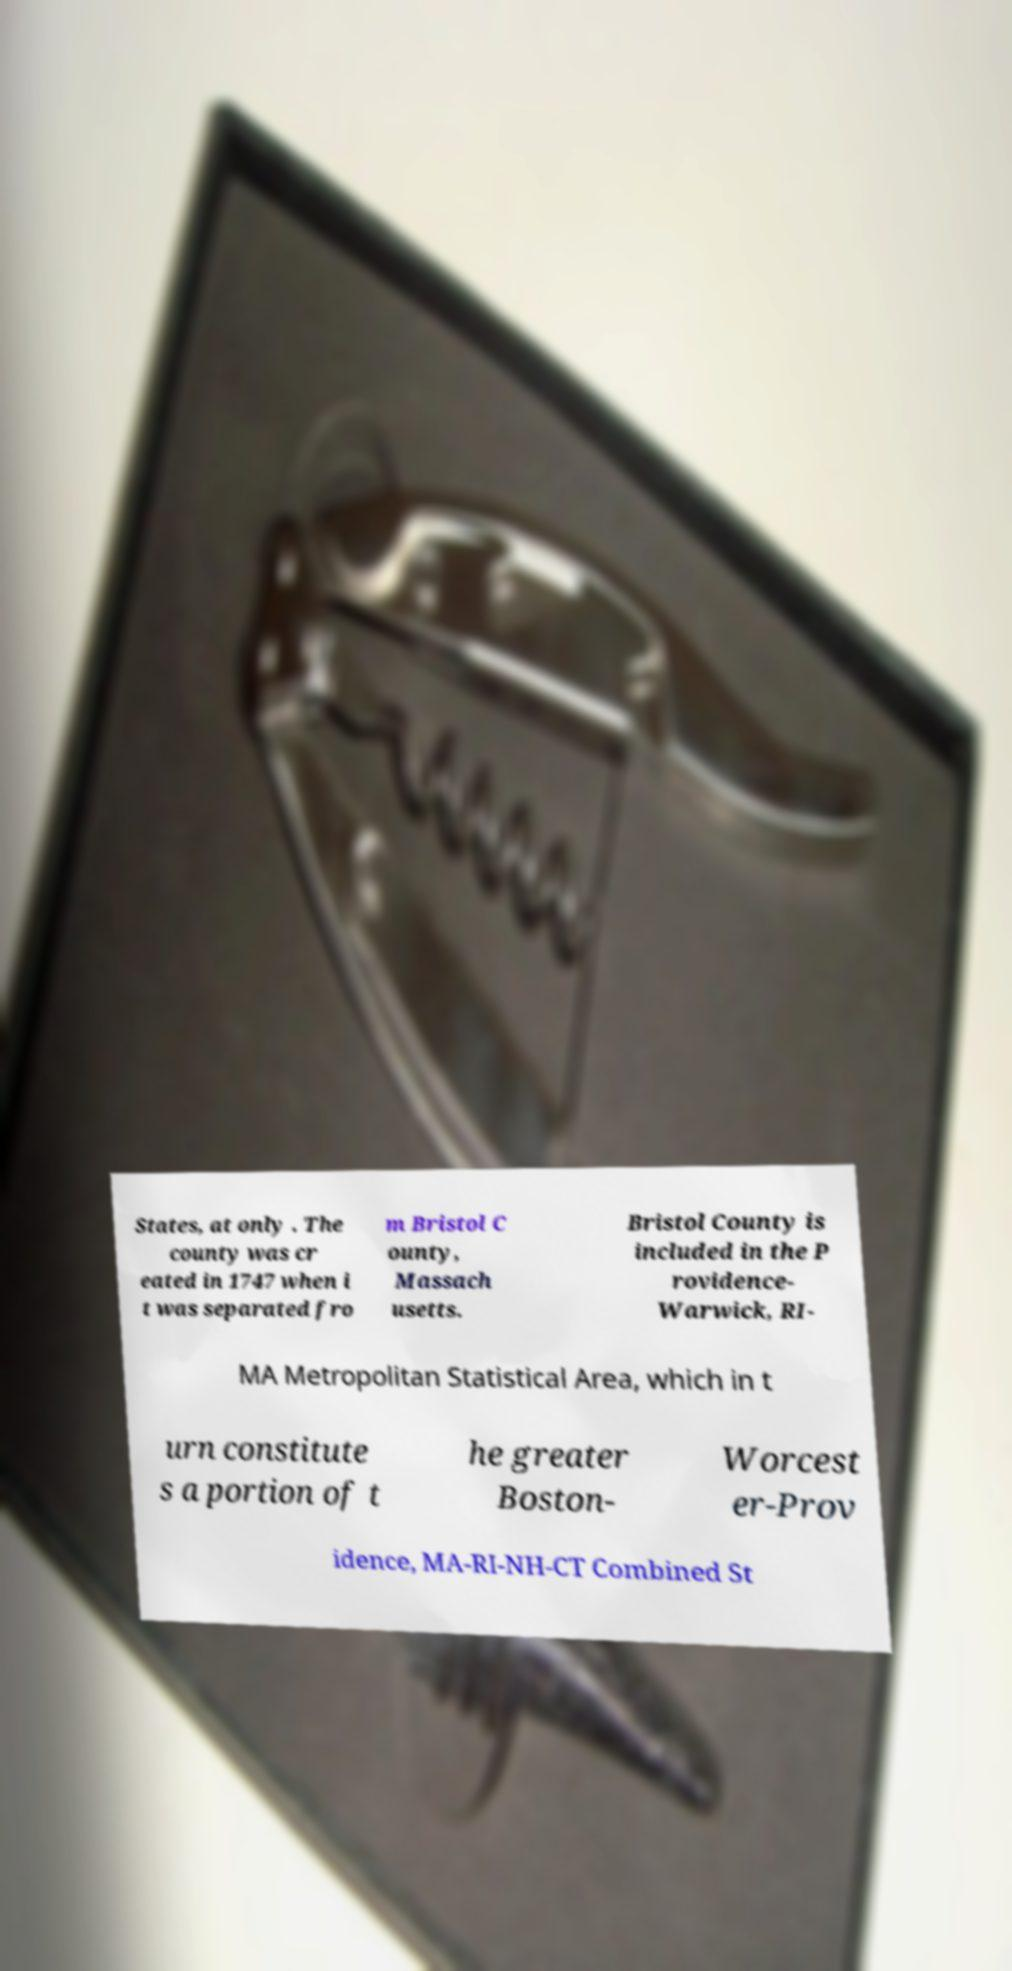Please read and relay the text visible in this image. What does it say? States, at only . The county was cr eated in 1747 when i t was separated fro m Bristol C ounty, Massach usetts. Bristol County is included in the P rovidence- Warwick, RI- MA Metropolitan Statistical Area, which in t urn constitute s a portion of t he greater Boston- Worcest er-Prov idence, MA-RI-NH-CT Combined St 